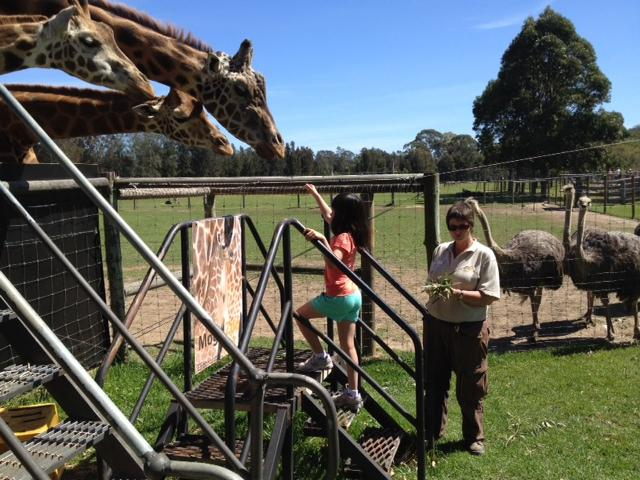Why is the short haired woman wearing a khaki shirt?

Choices:
A) fashion
B) staying cool
C) dress code
D) keeping warm dress code 